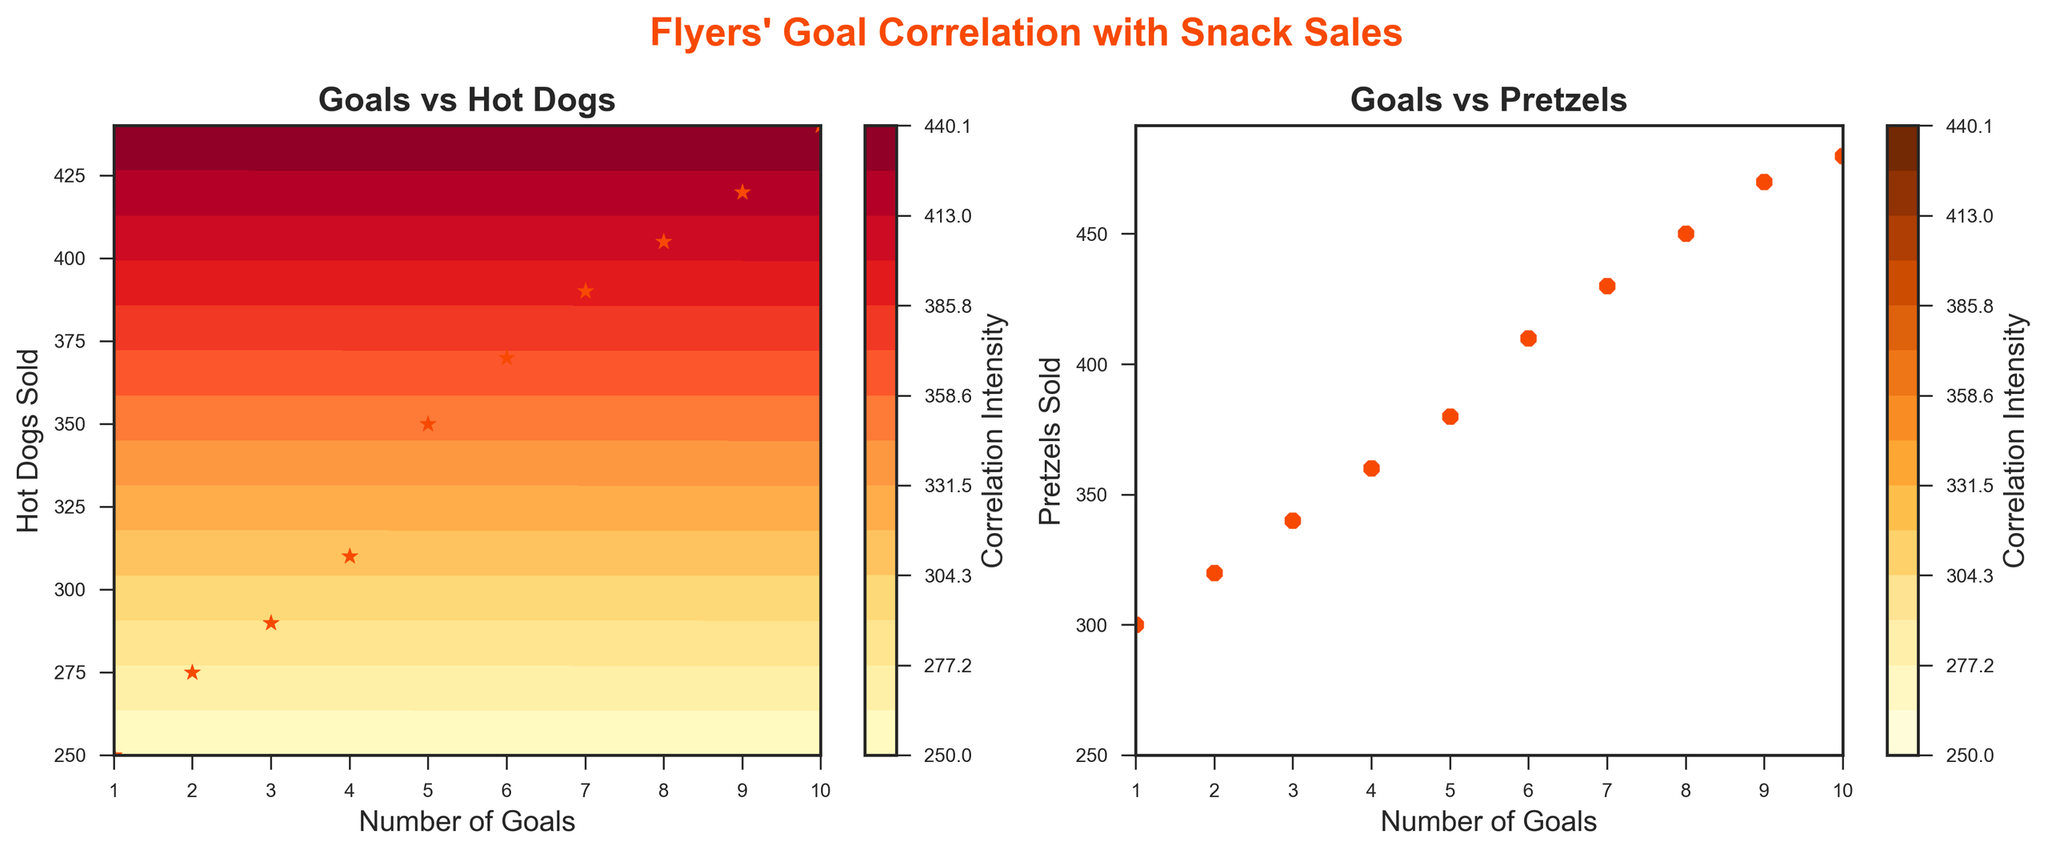How many data points are shown in both subplots? The subplots each illustrate the number of goals versus either hot dogs or pretzels sold. Each subplot has 10 data points, corresponding to the 10 home games.
Answer: 10 What does the title of the figure indicate? The title "Flyers' Goal Correlation with Snack Sales" suggests that the figure explores the relationship between the number of goals scored by the Flyers and the sales of hot dogs and pretzels during home games.
Answer: Flyers' Goal Correlation with Snack Sales Which subplot shows the relationship between goals scored and hot dogs sold? The left subplot's title is "Goals vs Hot Dogs," indicating it's the one illustrating the correlation between these two variables.
Answer: Left subplot What color is used to mark the data points in the "Goals vs Hot Dogs" subplot? In the "Goals vs Hot Dogs" subplot, the data points are marked with orange stars.
Answer: Orange Which variable appears on the x-axis of both subplots? Both subplots have the "Number of Goals" as the variable on the x-axis.
Answer: Number of Goals How does the pattern of correlation intensity differ between the two subplots? The "Goals vs Hot Dogs" subplot uses a color gradient from yellow to red to show correlation intensity, whereas the "Goals vs Pretzels" subplot uses a similar gradient but in a slightly duller yellow to brown range.
Answer: Different color gradients In terms of concession sales, which item is most correlated with a high number of goals: hot dogs or pretzels? By observing the distribution of data points and contour levels, it appears that pretzels have a broader range of higher sales as the number of goals increases, indicating a stronger correlation.
Answer: Pretzels At 5 goals scored, are more hot dogs or pretzels sold? By looking at the data points at the 5-goals mark in both subplots, there are more hot dogs (around 350) sold compared to pretzels (around 380).
Answer: Pretzels Does the variation in hot dog sales match the variation in pretzel sales as the number of goals increases? Both subplots indicate an upward trend, but the variation in pretzel sales seems to be slightly steeper than that in hot dog sales, suggesting a higher correlation with the number of goals scored.
Answer: No, pretzel sales vary more What is the maximum value on the color scales for correlation intensity? By checking the color bar legends on both subplots, the highest level for correlation intensity is indicated by the top-most color (dark red in the left and dark brown in the right) on the scale.
Answer: Top-most color on each subplot's color bar 